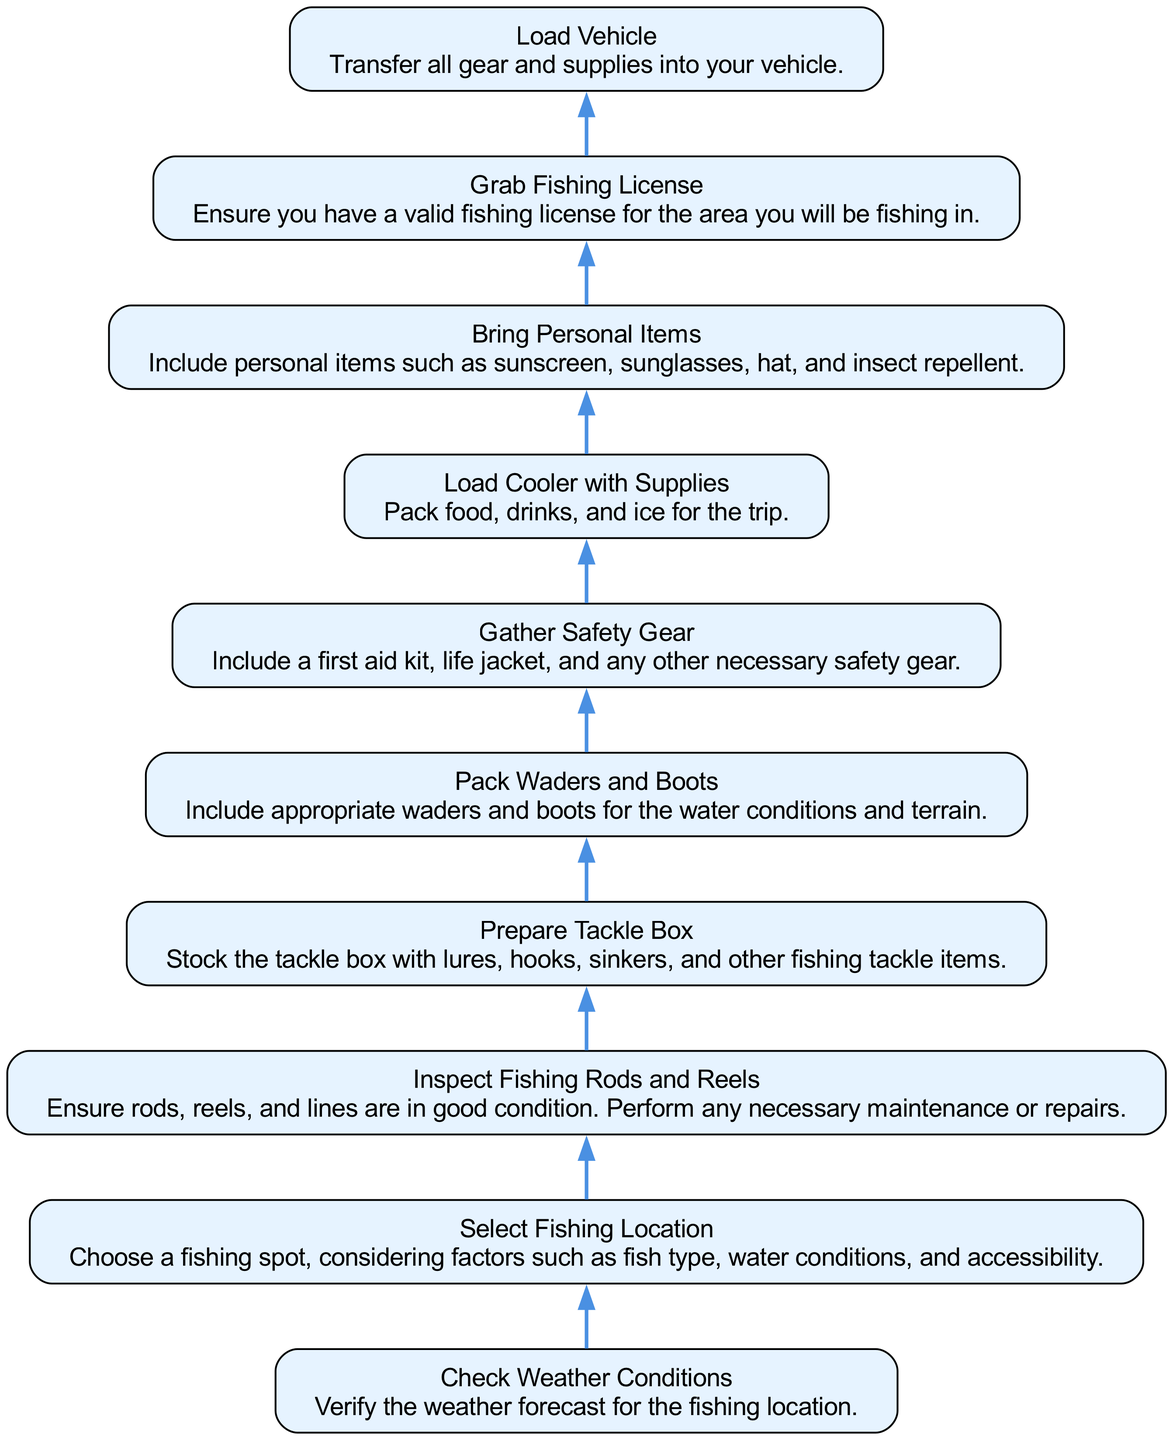What is the first step in the fishing trip preparation? The first step in the flow chart is "Check Weather Conditions," which indicates that verifying the weather forecast is the initial action to undertake.
Answer: Check Weather Conditions How many nodes are in the diagram? By counting the nodes depicted in the flow chart, there are ten distinct actions listed from top to bottom.
Answer: 10 What is the last step before loading the vehicle? The final step before loading the vehicle is "Grab Fishing License." This indicates you need to ensure you have a valid fishing license right before packing your gear into the vehicle.
Answer: Grab Fishing License Which step requires ensuring gear condition? The step that focuses on ensuring gear condition is "Inspect Fishing Rods and Reels." This indicates the importance of checking if the rods, reels, and lines are in good shape before going further in the preparation.
Answer: Inspect Fishing Rods and Reels What two steps directly follow "Prepare Tackle Box"? The steps that come directly after "Prepare Tackle Box" are "Pack Waders and Boots" and "Gather Safety Gear." This shows the flow of preparation continues with these essential items following the tackle box preparation.
Answer: Pack Waders and Boots, Gather Safety Gear What is the relationship between "Select Fishing Location" and "Load Vehicle"? "Select Fishing Location" is an earlier step in the preparation process. It must be completed before proceeding to "Load Vehicle" as the fishing location is crucial for subsequent preparations.
Answer: Sequential What is the content of the node that mentions packing food? The node that discusses packing food is "Load Cooler with Supplies," which specifies that food, drinks, and ice should be packed for the trip.
Answer: Load Cooler with Supplies What must be checked before "Inspect Fishing Rods and Reels"? Before "Inspect Fishing Rods and Reels," the step to "Select Fishing Location" must be completed. This establishes that knowing where you are going is a precursor to preparing any equipment.
Answer: Select Fishing Location How does "Gather Safety Gear" relate to "Bring Personal Items"? "Gather Safety Gear" comes before "Bring Personal Items" in the flowchart. It indicates that ensuring safety equipment is a priority before considering personal comforts like sunscreen and sunglasses.
Answer: Sequential 